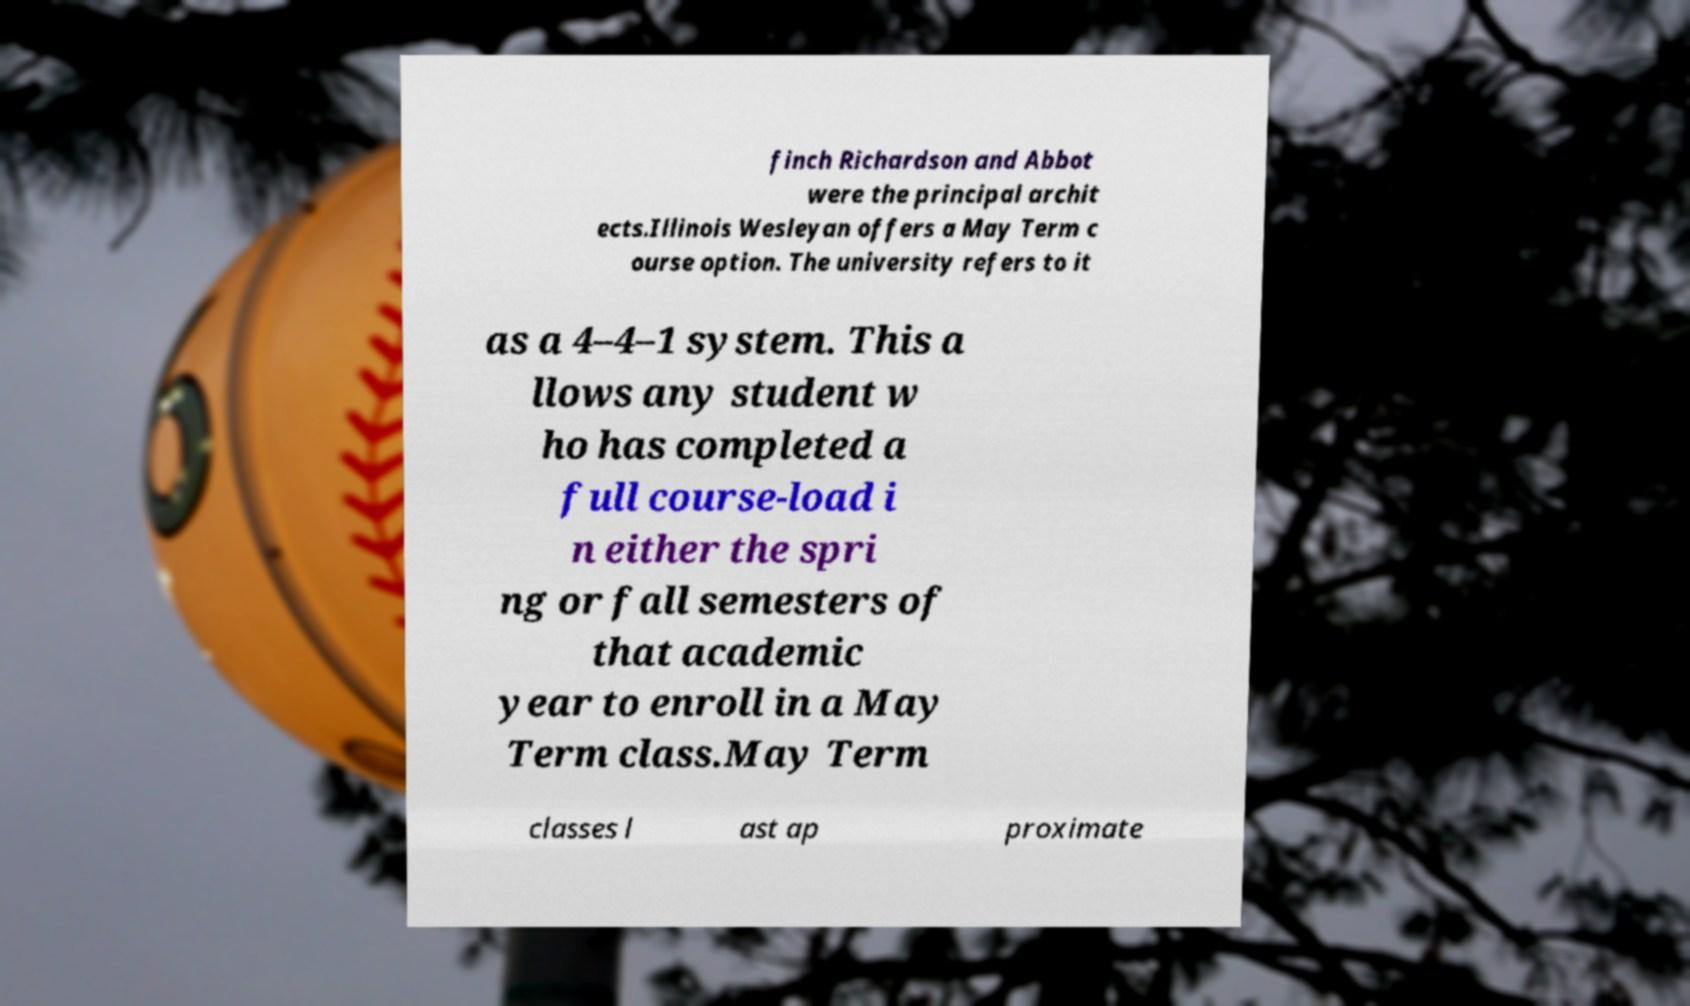Can you accurately transcribe the text from the provided image for me? finch Richardson and Abbot were the principal archit ects.Illinois Wesleyan offers a May Term c ourse option. The university refers to it as a 4–4–1 system. This a llows any student w ho has completed a full course-load i n either the spri ng or fall semesters of that academic year to enroll in a May Term class.May Term classes l ast ap proximate 